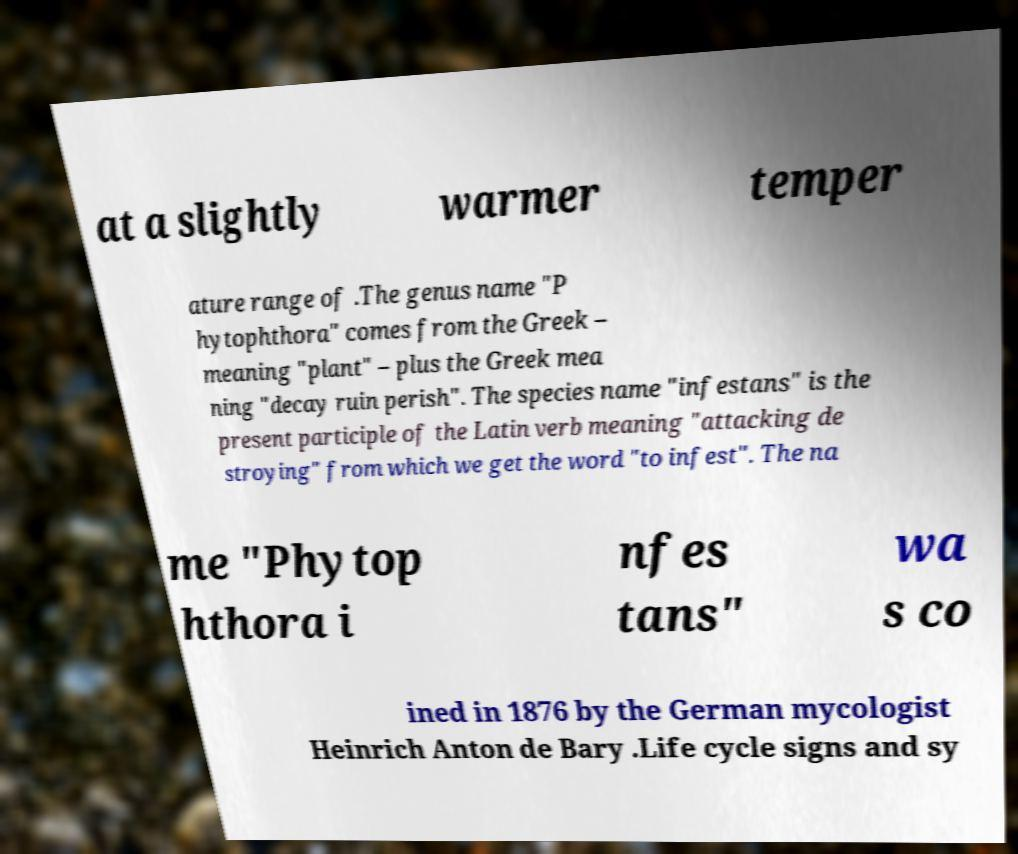For documentation purposes, I need the text within this image transcribed. Could you provide that? at a slightly warmer temper ature range of .The genus name "P hytophthora" comes from the Greek – meaning "plant" – plus the Greek mea ning "decay ruin perish". The species name "infestans" is the present participle of the Latin verb meaning "attacking de stroying" from which we get the word "to infest". The na me "Phytop hthora i nfes tans" wa s co ined in 1876 by the German mycologist Heinrich Anton de Bary .Life cycle signs and sy 